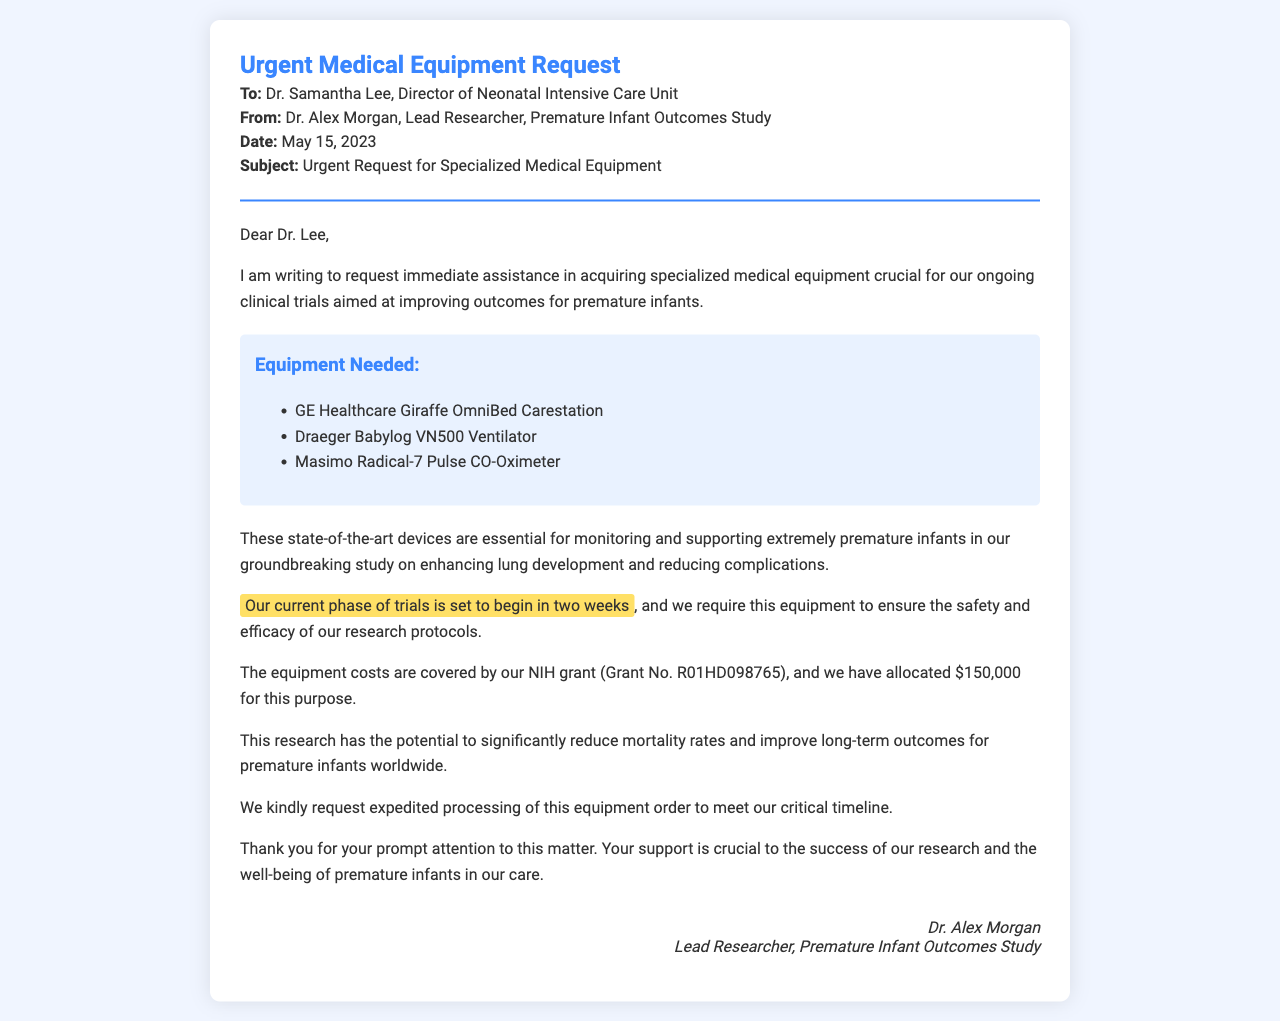What is the date of the fax? The date indicated in the document is May 15, 2023.
Answer: May 15, 2023 Who is the recipient of the fax? The document specifies that Dr. Samantha Lee is the recipient.
Answer: Dr. Samantha Lee What type of medical equipment is requested? The document lists three specific pieces of equipment needed for the trials.
Answer: GE Healthcare Giraffe OmniBed Carestation What is the budget allocated for equipment? The document states the allocated amount for equipment in the NIH grant.
Answer: $150,000 What is the purpose of the clinical trials mentioned? The document mentions the goal is to improve outcomes for premature infants.
Answer: Improve outcomes for premature infants How soon is the current phase of trials set to begin? The document clearly states the timeline for the start of the trials.
Answer: In two weeks What is the grant number mentioned in the document? The grant number provided in the document is essential for funding reference.
Answer: R01HD098765 Why is expedited processing requested for the equipment order? The document highlights the need for timely acquisition linked to trial scheduling.
Answer: To meet our critical timeline What is the full title of the sender? The document specifies the sender's full title in the closing section.
Answer: Lead Researcher, Premature Infant Outcomes Study 